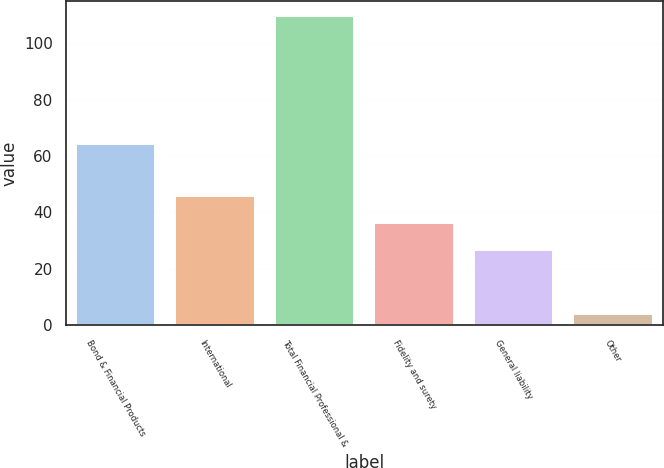<chart> <loc_0><loc_0><loc_500><loc_500><bar_chart><fcel>Bond & Financial Products<fcel>International<fcel>Total Financial Professional &<fcel>Fidelity and surety<fcel>General liability<fcel>Other<nl><fcel>64.2<fcel>45.84<fcel>109.62<fcel>36.22<fcel>26.6<fcel>3.8<nl></chart> 